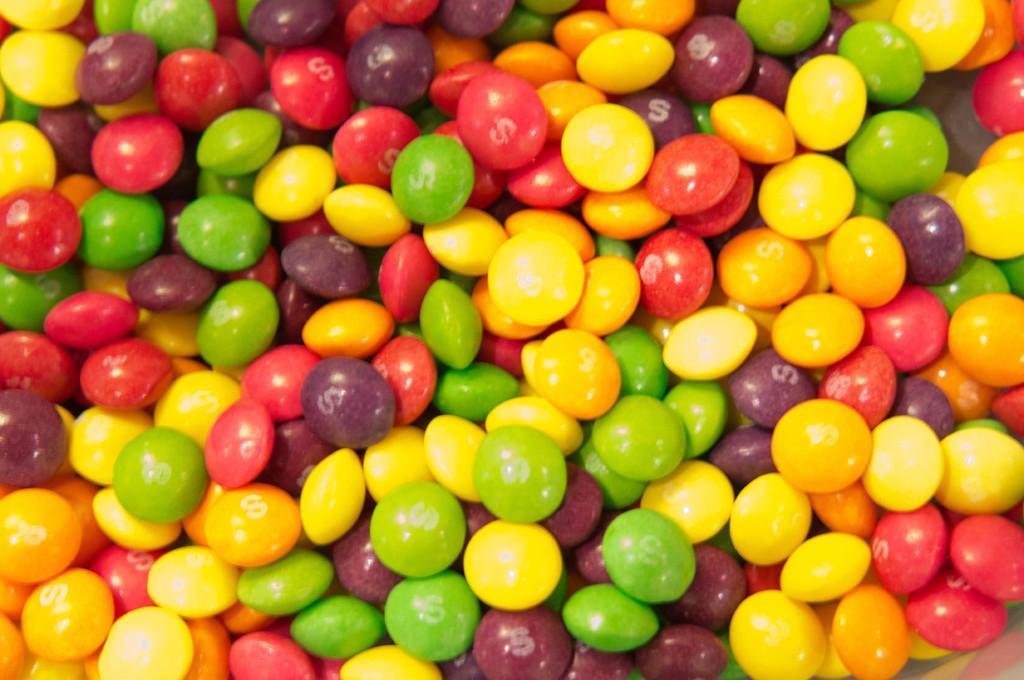Describe this image in one or two sentences. In this image we can see food item looks like candy. 